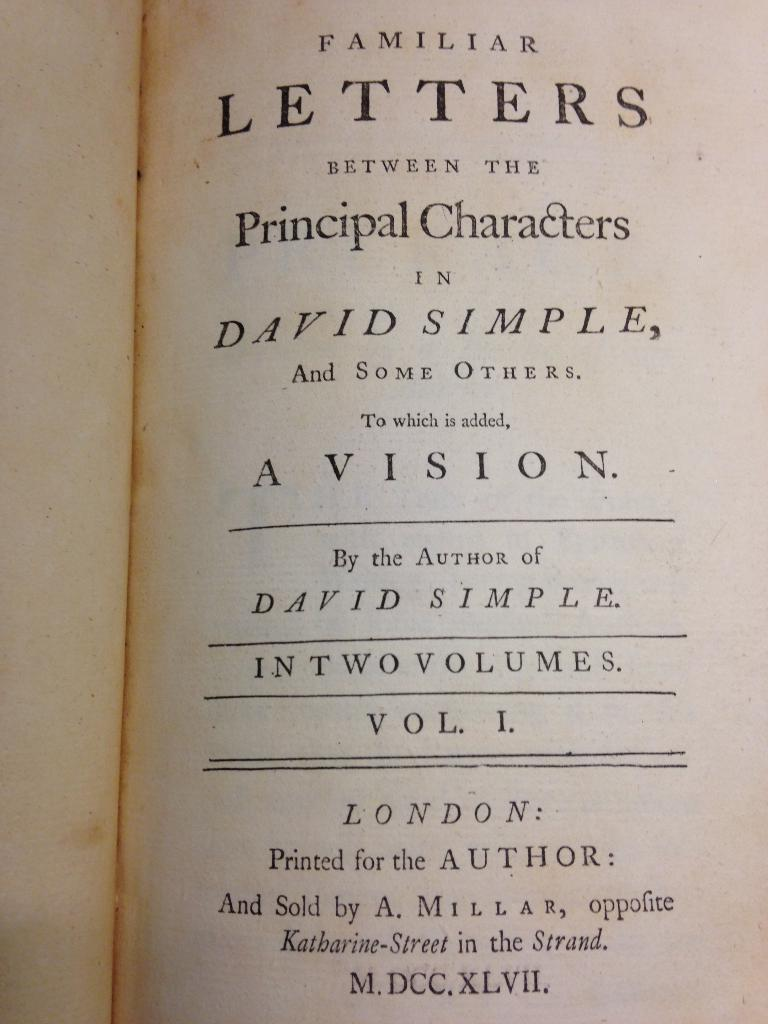<image>
Give a short and clear explanation of the subsequent image. Familar Letters between the principal characters in David Simple and some others book. 